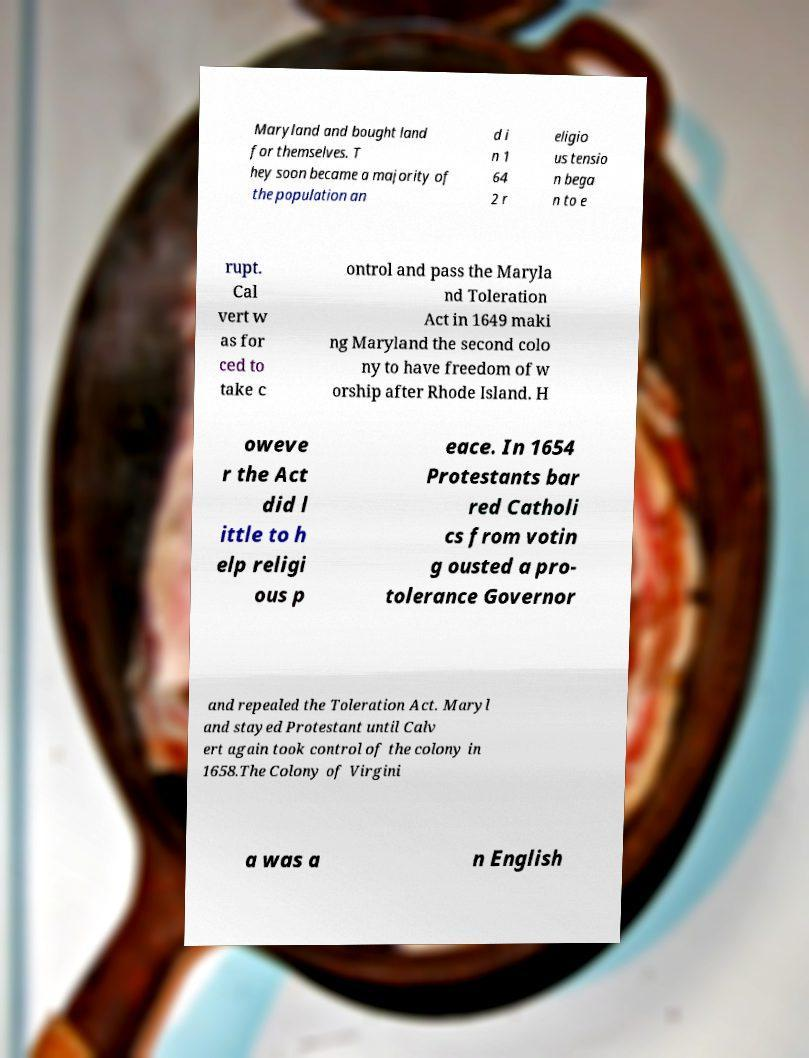For documentation purposes, I need the text within this image transcribed. Could you provide that? Maryland and bought land for themselves. T hey soon became a majority of the population an d i n 1 64 2 r eligio us tensio n bega n to e rupt. Cal vert w as for ced to take c ontrol and pass the Maryla nd Toleration Act in 1649 maki ng Maryland the second colo ny to have freedom of w orship after Rhode Island. H oweve r the Act did l ittle to h elp religi ous p eace. In 1654 Protestants bar red Catholi cs from votin g ousted a pro- tolerance Governor and repealed the Toleration Act. Maryl and stayed Protestant until Calv ert again took control of the colony in 1658.The Colony of Virgini a was a n English 